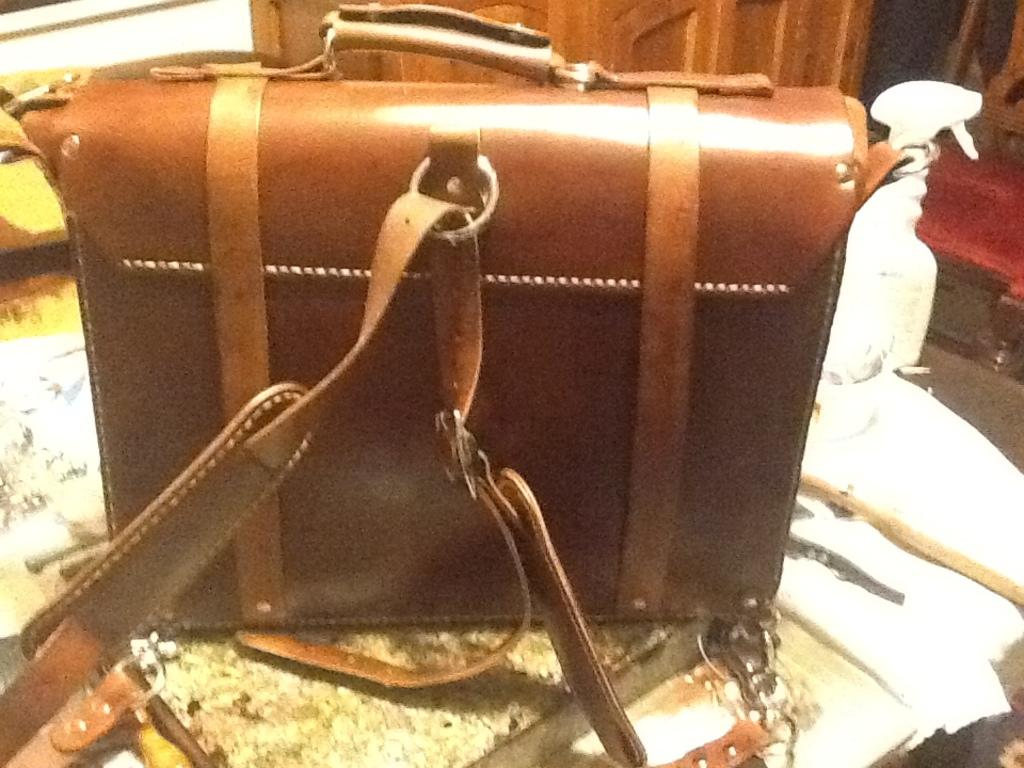What object is placed on the table in the image? There is a bag on the table in the image. What other object can be seen on the table? There is a spray bottle on the table. What can be seen in the background of the image? There is a door and a chair in the background of the image. What type of learning is the son doing in the image? There is no son present in the image, and therefore no learning activity can be observed. 